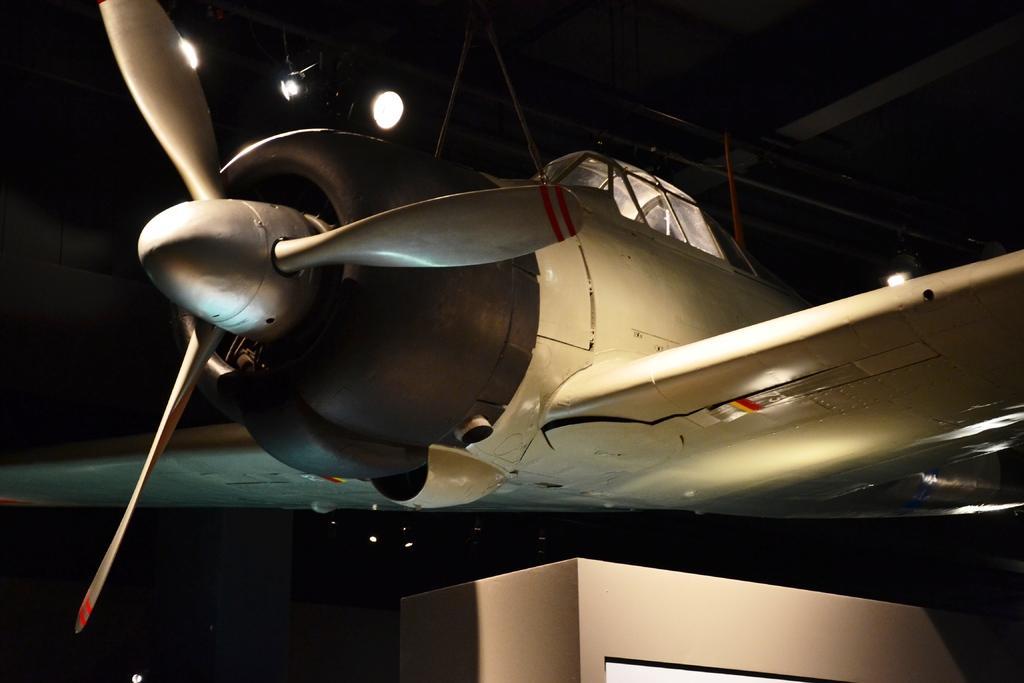Can you describe this image briefly? In this image, in the middle, we can see an airplane. In the background, we can see some lights and black color, at the bottom, we can see a box. 